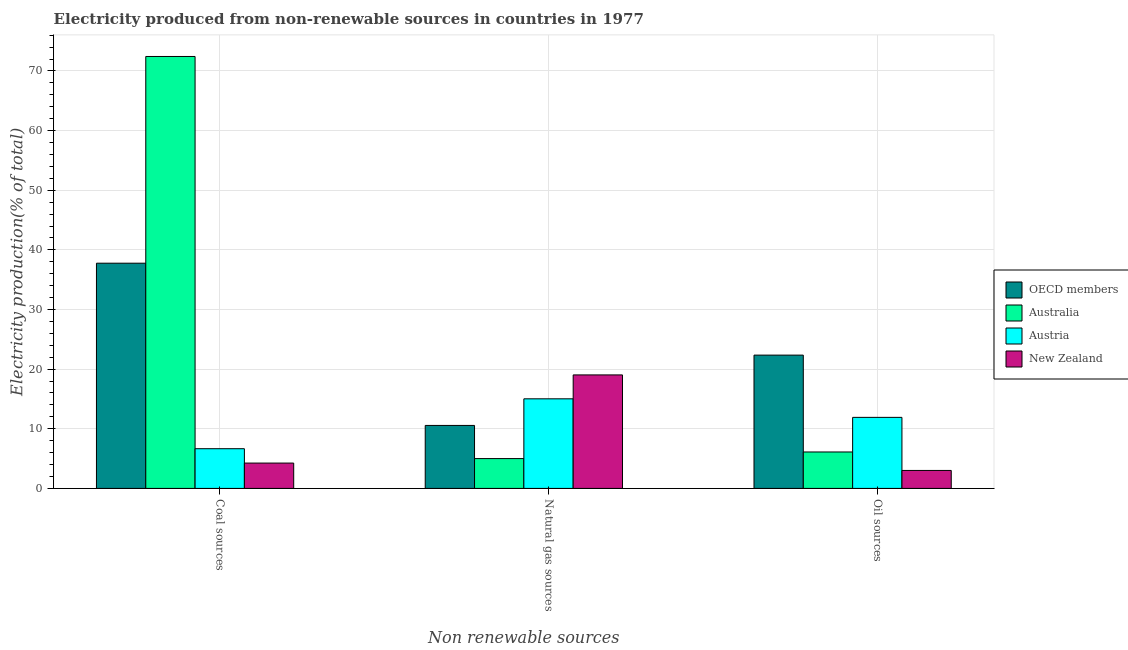How many groups of bars are there?
Provide a short and direct response. 3. Are the number of bars per tick equal to the number of legend labels?
Provide a short and direct response. Yes. Are the number of bars on each tick of the X-axis equal?
Keep it short and to the point. Yes. What is the label of the 3rd group of bars from the left?
Your response must be concise. Oil sources. What is the percentage of electricity produced by oil sources in Austria?
Give a very brief answer. 11.91. Across all countries, what is the maximum percentage of electricity produced by coal?
Ensure brevity in your answer.  72.43. Across all countries, what is the minimum percentage of electricity produced by natural gas?
Offer a terse response. 5. In which country was the percentage of electricity produced by natural gas minimum?
Keep it short and to the point. Australia. What is the total percentage of electricity produced by oil sources in the graph?
Give a very brief answer. 43.39. What is the difference between the percentage of electricity produced by coal in OECD members and that in New Zealand?
Offer a terse response. 33.51. What is the difference between the percentage of electricity produced by coal in Australia and the percentage of electricity produced by natural gas in New Zealand?
Your response must be concise. 53.4. What is the average percentage of electricity produced by coal per country?
Your answer should be compact. 30.28. What is the difference between the percentage of electricity produced by natural gas and percentage of electricity produced by coal in New Zealand?
Make the answer very short. 14.78. In how many countries, is the percentage of electricity produced by oil sources greater than 10 %?
Provide a succinct answer. 2. What is the ratio of the percentage of electricity produced by oil sources in OECD members to that in Australia?
Your answer should be very brief. 3.66. What is the difference between the highest and the second highest percentage of electricity produced by natural gas?
Offer a very short reply. 4.01. What is the difference between the highest and the lowest percentage of electricity produced by oil sources?
Make the answer very short. 19.34. In how many countries, is the percentage of electricity produced by coal greater than the average percentage of electricity produced by coal taken over all countries?
Keep it short and to the point. 2. What does the 2nd bar from the left in Oil sources represents?
Give a very brief answer. Australia. What does the 4th bar from the right in Natural gas sources represents?
Offer a terse response. OECD members. Is it the case that in every country, the sum of the percentage of electricity produced by coal and percentage of electricity produced by natural gas is greater than the percentage of electricity produced by oil sources?
Your response must be concise. Yes. How many countries are there in the graph?
Your response must be concise. 4. How are the legend labels stacked?
Your answer should be compact. Vertical. What is the title of the graph?
Keep it short and to the point. Electricity produced from non-renewable sources in countries in 1977. What is the label or title of the X-axis?
Provide a short and direct response. Non renewable sources. What is the label or title of the Y-axis?
Provide a succinct answer. Electricity production(% of total). What is the Electricity production(% of total) of OECD members in Coal sources?
Your response must be concise. 37.77. What is the Electricity production(% of total) in Australia in Coal sources?
Offer a very short reply. 72.43. What is the Electricity production(% of total) in Austria in Coal sources?
Provide a short and direct response. 6.66. What is the Electricity production(% of total) in New Zealand in Coal sources?
Offer a very short reply. 4.25. What is the Electricity production(% of total) of OECD members in Natural gas sources?
Make the answer very short. 10.56. What is the Electricity production(% of total) in Australia in Natural gas sources?
Offer a terse response. 5. What is the Electricity production(% of total) in Austria in Natural gas sources?
Your answer should be compact. 15.02. What is the Electricity production(% of total) of New Zealand in Natural gas sources?
Your answer should be compact. 19.03. What is the Electricity production(% of total) in OECD members in Oil sources?
Offer a very short reply. 22.35. What is the Electricity production(% of total) in Australia in Oil sources?
Your response must be concise. 6.11. What is the Electricity production(% of total) of Austria in Oil sources?
Ensure brevity in your answer.  11.91. What is the Electricity production(% of total) in New Zealand in Oil sources?
Give a very brief answer. 3.01. Across all Non renewable sources, what is the maximum Electricity production(% of total) of OECD members?
Offer a very short reply. 37.77. Across all Non renewable sources, what is the maximum Electricity production(% of total) in Australia?
Ensure brevity in your answer.  72.43. Across all Non renewable sources, what is the maximum Electricity production(% of total) in Austria?
Ensure brevity in your answer.  15.02. Across all Non renewable sources, what is the maximum Electricity production(% of total) of New Zealand?
Make the answer very short. 19.03. Across all Non renewable sources, what is the minimum Electricity production(% of total) in OECD members?
Your response must be concise. 10.56. Across all Non renewable sources, what is the minimum Electricity production(% of total) in Australia?
Ensure brevity in your answer.  5. Across all Non renewable sources, what is the minimum Electricity production(% of total) in Austria?
Ensure brevity in your answer.  6.66. Across all Non renewable sources, what is the minimum Electricity production(% of total) of New Zealand?
Provide a succinct answer. 3.01. What is the total Electricity production(% of total) of OECD members in the graph?
Your response must be concise. 70.68. What is the total Electricity production(% of total) in Australia in the graph?
Offer a terse response. 83.54. What is the total Electricity production(% of total) of Austria in the graph?
Make the answer very short. 33.59. What is the total Electricity production(% of total) in New Zealand in the graph?
Ensure brevity in your answer.  26.3. What is the difference between the Electricity production(% of total) of OECD members in Coal sources and that in Natural gas sources?
Your response must be concise. 27.2. What is the difference between the Electricity production(% of total) of Australia in Coal sources and that in Natural gas sources?
Ensure brevity in your answer.  67.43. What is the difference between the Electricity production(% of total) of Austria in Coal sources and that in Natural gas sources?
Provide a succinct answer. -8.37. What is the difference between the Electricity production(% of total) of New Zealand in Coal sources and that in Natural gas sources?
Give a very brief answer. -14.78. What is the difference between the Electricity production(% of total) in OECD members in Coal sources and that in Oil sources?
Your answer should be very brief. 15.41. What is the difference between the Electricity production(% of total) of Australia in Coal sources and that in Oil sources?
Offer a terse response. 66.32. What is the difference between the Electricity production(% of total) of Austria in Coal sources and that in Oil sources?
Make the answer very short. -5.26. What is the difference between the Electricity production(% of total) in New Zealand in Coal sources and that in Oil sources?
Give a very brief answer. 1.24. What is the difference between the Electricity production(% of total) in OECD members in Natural gas sources and that in Oil sources?
Your answer should be compact. -11.79. What is the difference between the Electricity production(% of total) of Australia in Natural gas sources and that in Oil sources?
Keep it short and to the point. -1.11. What is the difference between the Electricity production(% of total) of Austria in Natural gas sources and that in Oil sources?
Your answer should be compact. 3.11. What is the difference between the Electricity production(% of total) of New Zealand in Natural gas sources and that in Oil sources?
Your response must be concise. 16.02. What is the difference between the Electricity production(% of total) of OECD members in Coal sources and the Electricity production(% of total) of Australia in Natural gas sources?
Offer a terse response. 32.76. What is the difference between the Electricity production(% of total) of OECD members in Coal sources and the Electricity production(% of total) of Austria in Natural gas sources?
Your answer should be compact. 22.74. What is the difference between the Electricity production(% of total) of OECD members in Coal sources and the Electricity production(% of total) of New Zealand in Natural gas sources?
Provide a succinct answer. 18.73. What is the difference between the Electricity production(% of total) of Australia in Coal sources and the Electricity production(% of total) of Austria in Natural gas sources?
Keep it short and to the point. 57.41. What is the difference between the Electricity production(% of total) of Australia in Coal sources and the Electricity production(% of total) of New Zealand in Natural gas sources?
Give a very brief answer. 53.4. What is the difference between the Electricity production(% of total) in Austria in Coal sources and the Electricity production(% of total) in New Zealand in Natural gas sources?
Ensure brevity in your answer.  -12.38. What is the difference between the Electricity production(% of total) of OECD members in Coal sources and the Electricity production(% of total) of Australia in Oil sources?
Provide a succinct answer. 31.66. What is the difference between the Electricity production(% of total) of OECD members in Coal sources and the Electricity production(% of total) of Austria in Oil sources?
Provide a short and direct response. 25.85. What is the difference between the Electricity production(% of total) of OECD members in Coal sources and the Electricity production(% of total) of New Zealand in Oil sources?
Offer a terse response. 34.75. What is the difference between the Electricity production(% of total) of Australia in Coal sources and the Electricity production(% of total) of Austria in Oil sources?
Offer a very short reply. 60.52. What is the difference between the Electricity production(% of total) of Australia in Coal sources and the Electricity production(% of total) of New Zealand in Oil sources?
Ensure brevity in your answer.  69.42. What is the difference between the Electricity production(% of total) of Austria in Coal sources and the Electricity production(% of total) of New Zealand in Oil sources?
Ensure brevity in your answer.  3.64. What is the difference between the Electricity production(% of total) in OECD members in Natural gas sources and the Electricity production(% of total) in Australia in Oil sources?
Make the answer very short. 4.45. What is the difference between the Electricity production(% of total) of OECD members in Natural gas sources and the Electricity production(% of total) of Austria in Oil sources?
Your response must be concise. -1.35. What is the difference between the Electricity production(% of total) in OECD members in Natural gas sources and the Electricity production(% of total) in New Zealand in Oil sources?
Provide a short and direct response. 7.55. What is the difference between the Electricity production(% of total) of Australia in Natural gas sources and the Electricity production(% of total) of Austria in Oil sources?
Offer a terse response. -6.91. What is the difference between the Electricity production(% of total) in Australia in Natural gas sources and the Electricity production(% of total) in New Zealand in Oil sources?
Give a very brief answer. 1.99. What is the difference between the Electricity production(% of total) in Austria in Natural gas sources and the Electricity production(% of total) in New Zealand in Oil sources?
Provide a short and direct response. 12.01. What is the average Electricity production(% of total) of OECD members per Non renewable sources?
Provide a short and direct response. 23.56. What is the average Electricity production(% of total) of Australia per Non renewable sources?
Ensure brevity in your answer.  27.85. What is the average Electricity production(% of total) in Austria per Non renewable sources?
Provide a succinct answer. 11.2. What is the average Electricity production(% of total) of New Zealand per Non renewable sources?
Your response must be concise. 8.77. What is the difference between the Electricity production(% of total) in OECD members and Electricity production(% of total) in Australia in Coal sources?
Provide a succinct answer. -34.66. What is the difference between the Electricity production(% of total) of OECD members and Electricity production(% of total) of Austria in Coal sources?
Your response must be concise. 31.11. What is the difference between the Electricity production(% of total) of OECD members and Electricity production(% of total) of New Zealand in Coal sources?
Make the answer very short. 33.51. What is the difference between the Electricity production(% of total) of Australia and Electricity production(% of total) of Austria in Coal sources?
Provide a short and direct response. 65.77. What is the difference between the Electricity production(% of total) of Australia and Electricity production(% of total) of New Zealand in Coal sources?
Your answer should be compact. 68.18. What is the difference between the Electricity production(% of total) in Austria and Electricity production(% of total) in New Zealand in Coal sources?
Make the answer very short. 2.41. What is the difference between the Electricity production(% of total) in OECD members and Electricity production(% of total) in Australia in Natural gas sources?
Ensure brevity in your answer.  5.56. What is the difference between the Electricity production(% of total) of OECD members and Electricity production(% of total) of Austria in Natural gas sources?
Offer a very short reply. -4.46. What is the difference between the Electricity production(% of total) of OECD members and Electricity production(% of total) of New Zealand in Natural gas sources?
Give a very brief answer. -8.47. What is the difference between the Electricity production(% of total) in Australia and Electricity production(% of total) in Austria in Natural gas sources?
Your answer should be compact. -10.02. What is the difference between the Electricity production(% of total) in Australia and Electricity production(% of total) in New Zealand in Natural gas sources?
Provide a succinct answer. -14.03. What is the difference between the Electricity production(% of total) in Austria and Electricity production(% of total) in New Zealand in Natural gas sources?
Give a very brief answer. -4.01. What is the difference between the Electricity production(% of total) in OECD members and Electricity production(% of total) in Australia in Oil sources?
Make the answer very short. 16.24. What is the difference between the Electricity production(% of total) in OECD members and Electricity production(% of total) in Austria in Oil sources?
Give a very brief answer. 10.44. What is the difference between the Electricity production(% of total) of OECD members and Electricity production(% of total) of New Zealand in Oil sources?
Give a very brief answer. 19.34. What is the difference between the Electricity production(% of total) in Australia and Electricity production(% of total) in Austria in Oil sources?
Your response must be concise. -5.8. What is the difference between the Electricity production(% of total) of Australia and Electricity production(% of total) of New Zealand in Oil sources?
Your answer should be compact. 3.1. What is the difference between the Electricity production(% of total) of Austria and Electricity production(% of total) of New Zealand in Oil sources?
Your answer should be very brief. 8.9. What is the ratio of the Electricity production(% of total) in OECD members in Coal sources to that in Natural gas sources?
Offer a very short reply. 3.58. What is the ratio of the Electricity production(% of total) of Australia in Coal sources to that in Natural gas sources?
Offer a very short reply. 14.48. What is the ratio of the Electricity production(% of total) of Austria in Coal sources to that in Natural gas sources?
Offer a terse response. 0.44. What is the ratio of the Electricity production(% of total) in New Zealand in Coal sources to that in Natural gas sources?
Provide a succinct answer. 0.22. What is the ratio of the Electricity production(% of total) in OECD members in Coal sources to that in Oil sources?
Ensure brevity in your answer.  1.69. What is the ratio of the Electricity production(% of total) in Australia in Coal sources to that in Oil sources?
Make the answer very short. 11.85. What is the ratio of the Electricity production(% of total) in Austria in Coal sources to that in Oil sources?
Your answer should be very brief. 0.56. What is the ratio of the Electricity production(% of total) in New Zealand in Coal sources to that in Oil sources?
Offer a terse response. 1.41. What is the ratio of the Electricity production(% of total) of OECD members in Natural gas sources to that in Oil sources?
Offer a terse response. 0.47. What is the ratio of the Electricity production(% of total) in Australia in Natural gas sources to that in Oil sources?
Give a very brief answer. 0.82. What is the ratio of the Electricity production(% of total) of Austria in Natural gas sources to that in Oil sources?
Your answer should be very brief. 1.26. What is the ratio of the Electricity production(% of total) in New Zealand in Natural gas sources to that in Oil sources?
Offer a very short reply. 6.31. What is the difference between the highest and the second highest Electricity production(% of total) of OECD members?
Make the answer very short. 15.41. What is the difference between the highest and the second highest Electricity production(% of total) of Australia?
Keep it short and to the point. 66.32. What is the difference between the highest and the second highest Electricity production(% of total) in Austria?
Offer a terse response. 3.11. What is the difference between the highest and the second highest Electricity production(% of total) of New Zealand?
Provide a short and direct response. 14.78. What is the difference between the highest and the lowest Electricity production(% of total) of OECD members?
Provide a succinct answer. 27.2. What is the difference between the highest and the lowest Electricity production(% of total) of Australia?
Give a very brief answer. 67.43. What is the difference between the highest and the lowest Electricity production(% of total) of Austria?
Keep it short and to the point. 8.37. What is the difference between the highest and the lowest Electricity production(% of total) in New Zealand?
Your response must be concise. 16.02. 